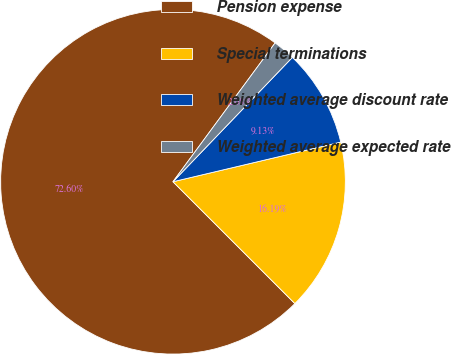Convert chart to OTSL. <chart><loc_0><loc_0><loc_500><loc_500><pie_chart><fcel>Pension expense<fcel>Special terminations<fcel>Weighted average discount rate<fcel>Weighted average expected rate<nl><fcel>72.6%<fcel>16.19%<fcel>9.13%<fcel>2.08%<nl></chart> 